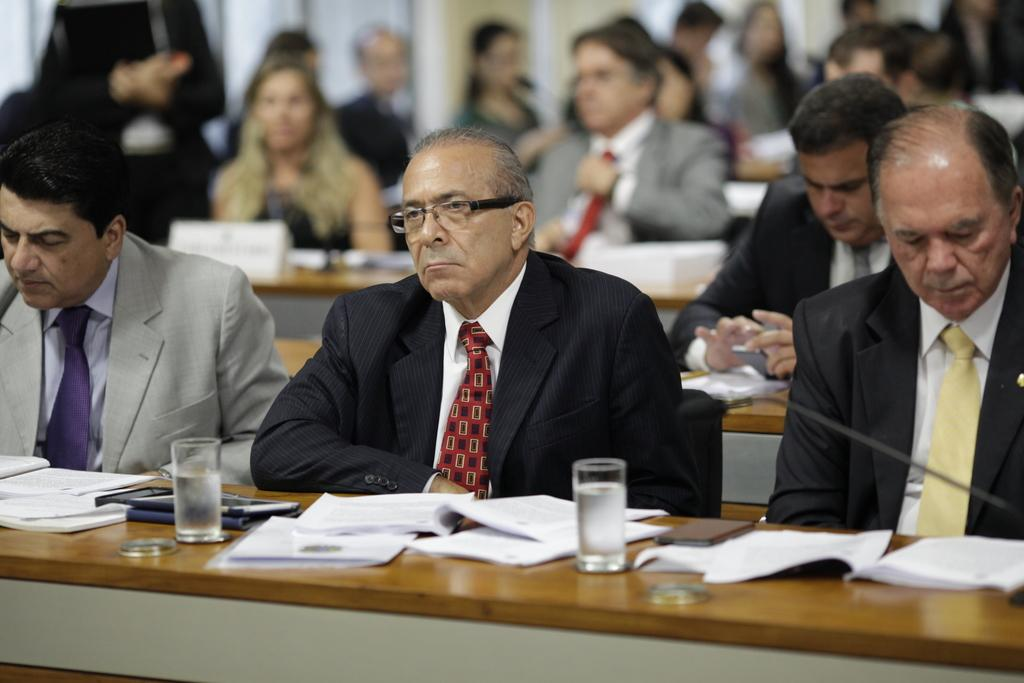What are the people in the image doing? The people in the image are sitting. What is in front of the people? There is a table in front of the people. What objects can be seen on the table? There is a book, a mobile, and glasses on the table. Can you see any visible veins on the people in the image? There is no information about the visibility of veins on the people in the image. How many ladybugs are crawling on the table in the image? There are no ladybugs present in the image. 